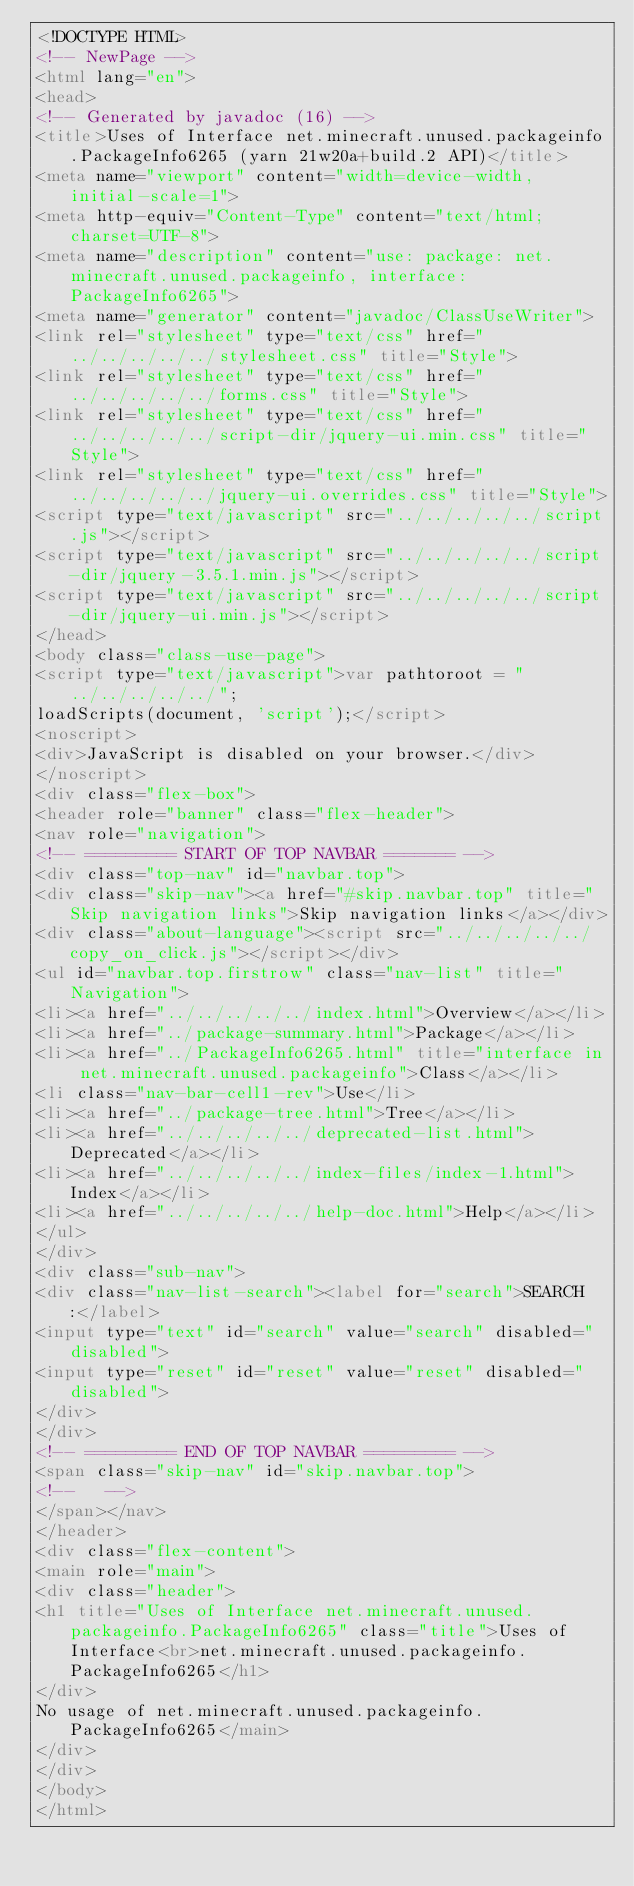Convert code to text. <code><loc_0><loc_0><loc_500><loc_500><_HTML_><!DOCTYPE HTML>
<!-- NewPage -->
<html lang="en">
<head>
<!-- Generated by javadoc (16) -->
<title>Uses of Interface net.minecraft.unused.packageinfo.PackageInfo6265 (yarn 21w20a+build.2 API)</title>
<meta name="viewport" content="width=device-width, initial-scale=1">
<meta http-equiv="Content-Type" content="text/html; charset=UTF-8">
<meta name="description" content="use: package: net.minecraft.unused.packageinfo, interface: PackageInfo6265">
<meta name="generator" content="javadoc/ClassUseWriter">
<link rel="stylesheet" type="text/css" href="../../../../../stylesheet.css" title="Style">
<link rel="stylesheet" type="text/css" href="../../../../../forms.css" title="Style">
<link rel="stylesheet" type="text/css" href="../../../../../script-dir/jquery-ui.min.css" title="Style">
<link rel="stylesheet" type="text/css" href="../../../../../jquery-ui.overrides.css" title="Style">
<script type="text/javascript" src="../../../../../script.js"></script>
<script type="text/javascript" src="../../../../../script-dir/jquery-3.5.1.min.js"></script>
<script type="text/javascript" src="../../../../../script-dir/jquery-ui.min.js"></script>
</head>
<body class="class-use-page">
<script type="text/javascript">var pathtoroot = "../../../../../";
loadScripts(document, 'script');</script>
<noscript>
<div>JavaScript is disabled on your browser.</div>
</noscript>
<div class="flex-box">
<header role="banner" class="flex-header">
<nav role="navigation">
<!-- ========= START OF TOP NAVBAR ======= -->
<div class="top-nav" id="navbar.top">
<div class="skip-nav"><a href="#skip.navbar.top" title="Skip navigation links">Skip navigation links</a></div>
<div class="about-language"><script src="../../../../../copy_on_click.js"></script></div>
<ul id="navbar.top.firstrow" class="nav-list" title="Navigation">
<li><a href="../../../../../index.html">Overview</a></li>
<li><a href="../package-summary.html">Package</a></li>
<li><a href="../PackageInfo6265.html" title="interface in net.minecraft.unused.packageinfo">Class</a></li>
<li class="nav-bar-cell1-rev">Use</li>
<li><a href="../package-tree.html">Tree</a></li>
<li><a href="../../../../../deprecated-list.html">Deprecated</a></li>
<li><a href="../../../../../index-files/index-1.html">Index</a></li>
<li><a href="../../../../../help-doc.html">Help</a></li>
</ul>
</div>
<div class="sub-nav">
<div class="nav-list-search"><label for="search">SEARCH:</label>
<input type="text" id="search" value="search" disabled="disabled">
<input type="reset" id="reset" value="reset" disabled="disabled">
</div>
</div>
<!-- ========= END OF TOP NAVBAR ========= -->
<span class="skip-nav" id="skip.navbar.top">
<!--   -->
</span></nav>
</header>
<div class="flex-content">
<main role="main">
<div class="header">
<h1 title="Uses of Interface net.minecraft.unused.packageinfo.PackageInfo6265" class="title">Uses of Interface<br>net.minecraft.unused.packageinfo.PackageInfo6265</h1>
</div>
No usage of net.minecraft.unused.packageinfo.PackageInfo6265</main>
</div>
</div>
</body>
</html>
</code> 